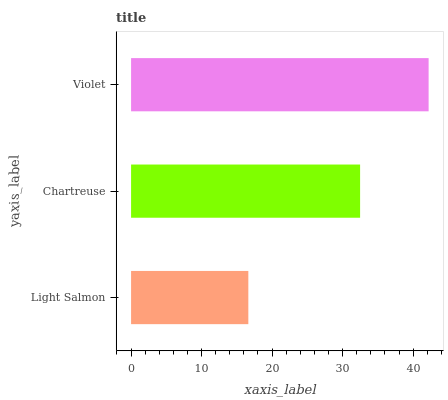Is Light Salmon the minimum?
Answer yes or no. Yes. Is Violet the maximum?
Answer yes or no. Yes. Is Chartreuse the minimum?
Answer yes or no. No. Is Chartreuse the maximum?
Answer yes or no. No. Is Chartreuse greater than Light Salmon?
Answer yes or no. Yes. Is Light Salmon less than Chartreuse?
Answer yes or no. Yes. Is Light Salmon greater than Chartreuse?
Answer yes or no. No. Is Chartreuse less than Light Salmon?
Answer yes or no. No. Is Chartreuse the high median?
Answer yes or no. Yes. Is Chartreuse the low median?
Answer yes or no. Yes. Is Violet the high median?
Answer yes or no. No. Is Light Salmon the low median?
Answer yes or no. No. 